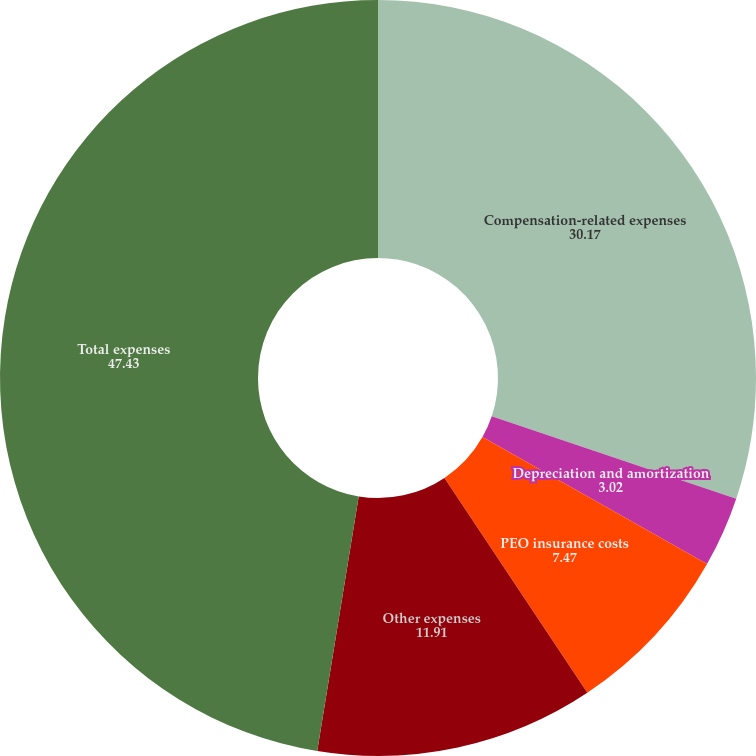<chart> <loc_0><loc_0><loc_500><loc_500><pie_chart><fcel>Compensation-related expenses<fcel>Depreciation and amortization<fcel>PEO insurance costs<fcel>Other expenses<fcel>Total expenses<nl><fcel>30.17%<fcel>3.02%<fcel>7.47%<fcel>11.91%<fcel>47.43%<nl></chart> 